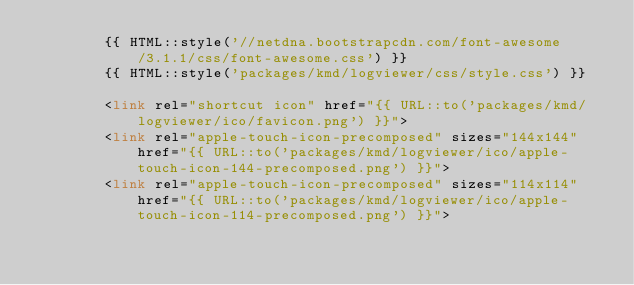<code> <loc_0><loc_0><loc_500><loc_500><_PHP_>        {{ HTML::style('//netdna.bootstrapcdn.com/font-awesome/3.1.1/css/font-awesome.css') }}
        {{ HTML::style('packages/kmd/logviewer/css/style.css') }}

        <link rel="shortcut icon" href="{{ URL::to('packages/kmd/logviewer/ico/favicon.png') }}">
        <link rel="apple-touch-icon-precomposed" sizes="144x144" href="{{ URL::to('packages/kmd/logviewer/ico/apple-touch-icon-144-precomposed.png') }}">
        <link rel="apple-touch-icon-precomposed" sizes="114x114" href="{{ URL::to('packages/kmd/logviewer/ico/apple-touch-icon-114-precomposed.png') }}"></code> 